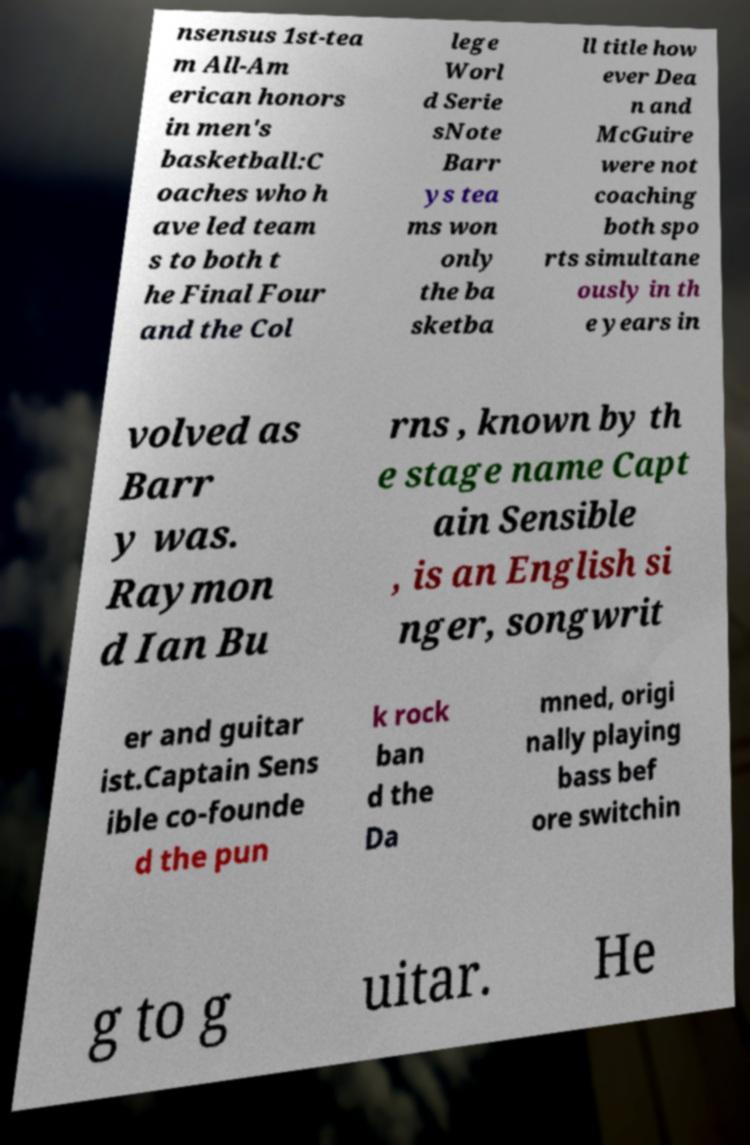For documentation purposes, I need the text within this image transcribed. Could you provide that? nsensus 1st-tea m All-Am erican honors in men's basketball:C oaches who h ave led team s to both t he Final Four and the Col lege Worl d Serie sNote Barr ys tea ms won only the ba sketba ll title how ever Dea n and McGuire were not coaching both spo rts simultane ously in th e years in volved as Barr y was. Raymon d Ian Bu rns , known by th e stage name Capt ain Sensible , is an English si nger, songwrit er and guitar ist.Captain Sens ible co-founde d the pun k rock ban d the Da mned, origi nally playing bass bef ore switchin g to g uitar. He 